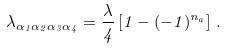<formula> <loc_0><loc_0><loc_500><loc_500>\lambda _ { \alpha _ { 1 } \alpha _ { 2 } \alpha _ { 3 } \alpha _ { 4 } } = { \frac { \lambda } { 4 } } \left [ 1 - ( - 1 ) ^ { n _ { a } } \right ] \, .</formula> 